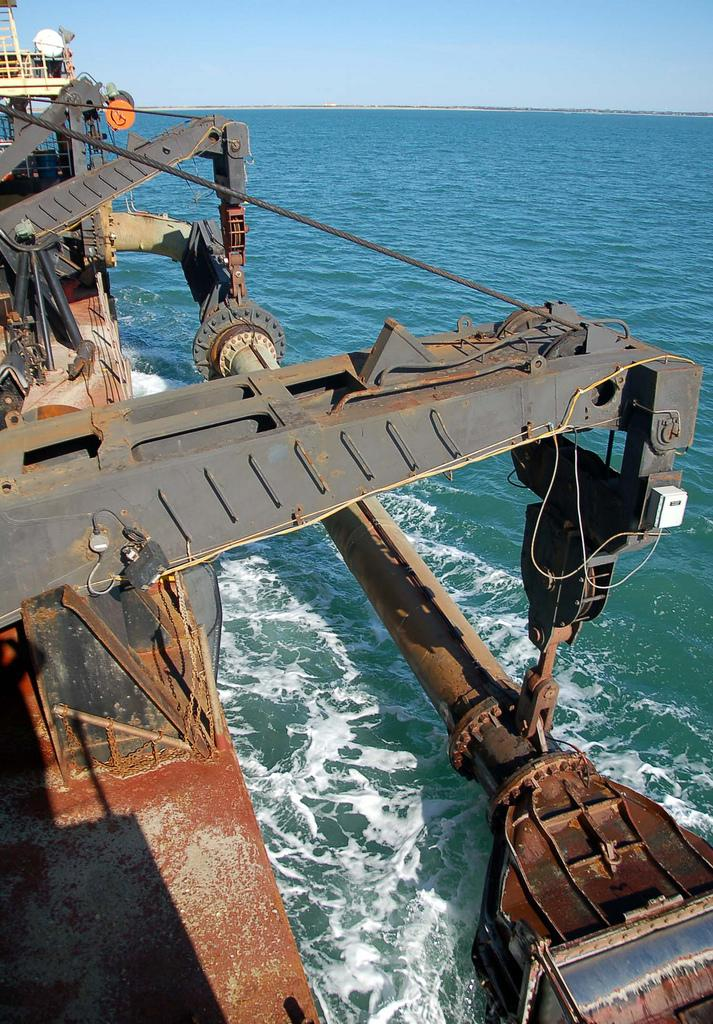What can be seen in the sky in the image? The sky is visible in the image. What is present in the water in the image? There is a ship in the water in the image. Where is the flame located in the image? There is no flame present in the image. What type of plant can be seen growing near the water in the image? There is no plant visible in the image; it only features the sky and a ship in the water. 